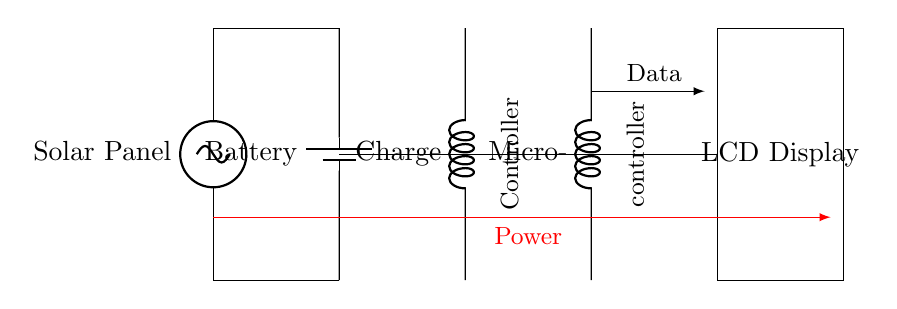What is the primary power source for this circuit? The primary power source is a Solar Panel, which converts sunlight into electrical energy for the circuit.
Answer: Solar Panel What component regulates the power supply to the microcontroller? The component that regulates the power supply is the Charge Controller. Its job is to ensure that the battery is charged correctly and prevents overcharging.
Answer: Charge Controller How many main components are present in this circuit? The main components are the Solar Panel, Battery, Charge Controller, Microcontroller, and LCD Display, totaling five components.
Answer: Five What is the purpose of the battery in this circuit? The battery stores electrical energy produced by the Solar Panel for later use, allowing the system to operate even when there is no sunlight.
Answer: Energy storage What does the arrow labeled "Data" represent in this circuit? The arrow labeled "Data" indicates the flow of information from the Microcontroller to the LCD Display, meaning the microcontroller sends processed data to be displayed.
Answer: Data flow Which component is responsible for displaying information? The component responsible for displaying information is the LCD Display, which presents the data processed by the Microcontroller to the users.
Answer: LCD Display 